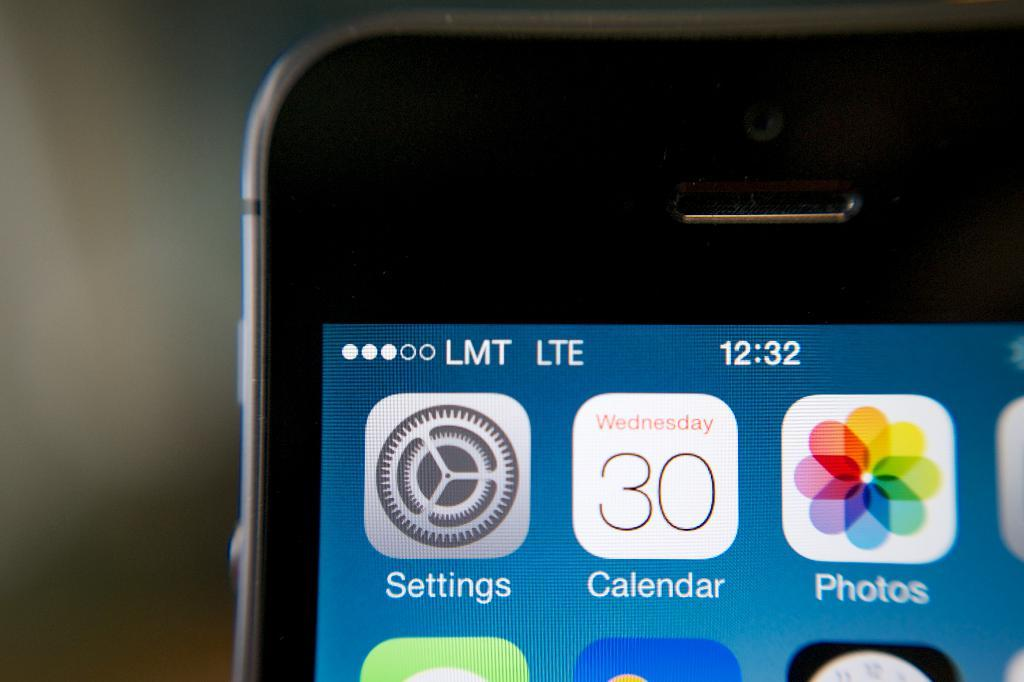<image>
Summarize the visual content of the image. A iPhone with a Settings, Calendar and Photos app. 